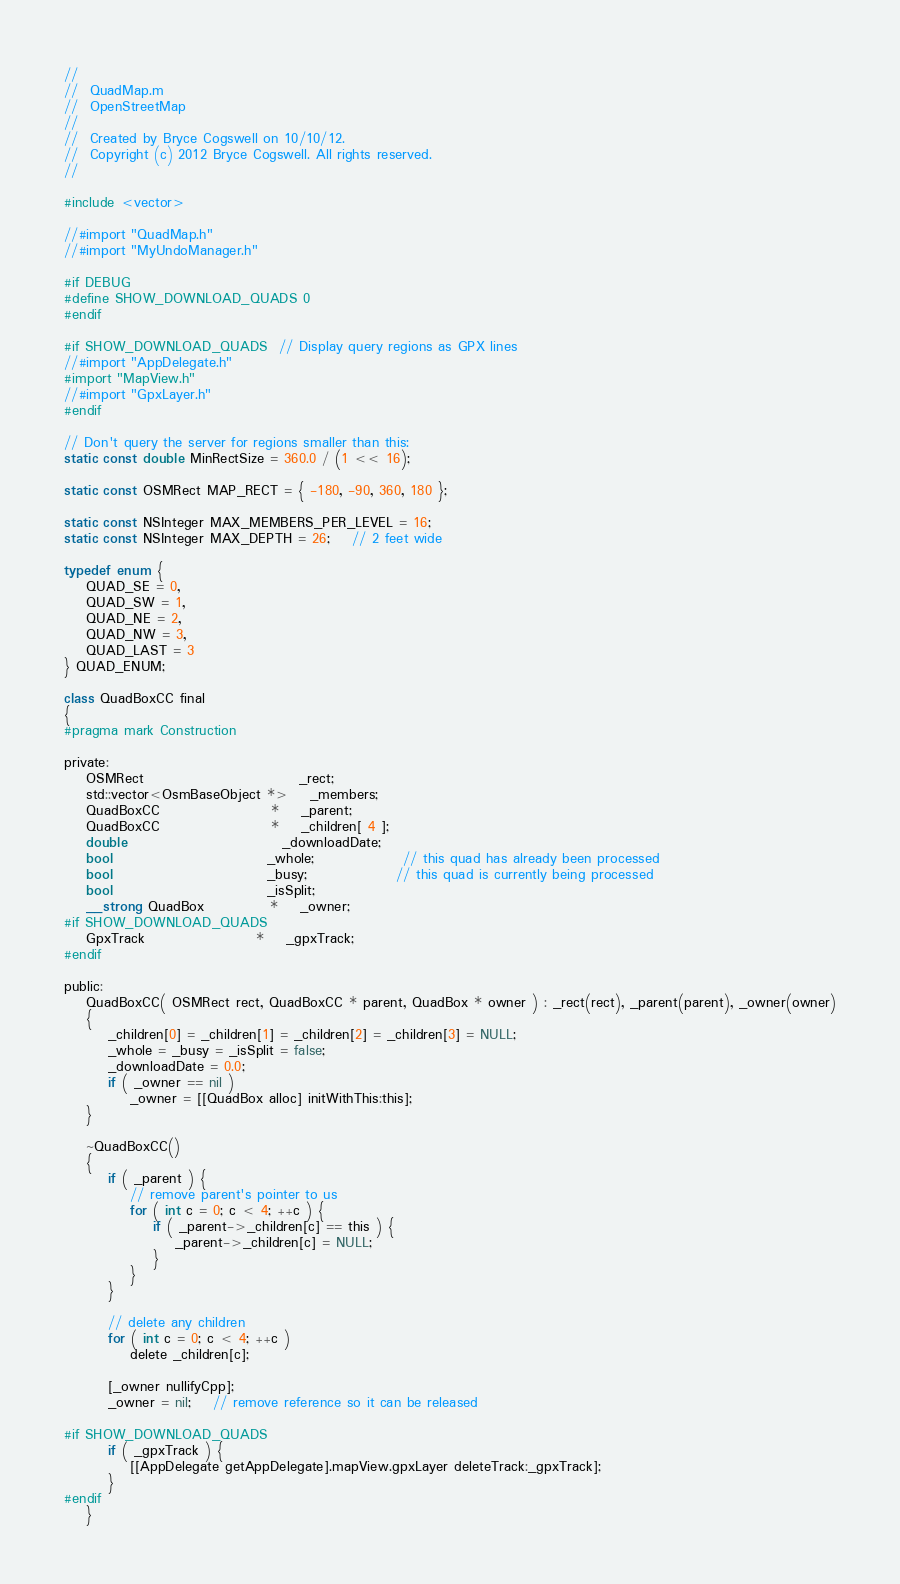Convert code to text. <code><loc_0><loc_0><loc_500><loc_500><_ObjectiveC_>//
//  QuadMap.m
//  OpenStreetMap
//
//  Created by Bryce Cogswell on 10/10/12.
//  Copyright (c) 2012 Bryce Cogswell. All rights reserved.
//

#include <vector>

//#import "QuadMap.h"
//#import "MyUndoManager.h"

#if DEBUG
#define SHOW_DOWNLOAD_QUADS 0
#endif

#if SHOW_DOWNLOAD_QUADS	// Display query regions as GPX lines
//#import "AppDelegate.h"
#import "MapView.h"
//#import "GpxLayer.h"
#endif

// Don't query the server for regions smaller than this:
static const double MinRectSize = 360.0 / (1 << 16);

static const OSMRect MAP_RECT = { -180, -90, 360, 180 };

static const NSInteger MAX_MEMBERS_PER_LEVEL = 16;
static const NSInteger MAX_DEPTH = 26;	// 2 feet wide

typedef enum {
	QUAD_SE = 0,
	QUAD_SW = 1,
	QUAD_NE = 2,
	QUAD_NW = 3,
	QUAD_LAST = 3
} QUAD_ENUM;

class QuadBoxCC final
{
#pragma mark Construction

private:
	OSMRect							_rect;
	std::vector<OsmBaseObject *>	_members;
	QuadBoxCC					*	_parent;
	QuadBoxCC					*	_children[ 4 ];
	double							_downloadDate;
	bool							_whole;				// this quad has already been processed
	bool							_busy;				// this quad is currently being processed
	bool							_isSplit;
	__strong QuadBox			*	_owner;
#if SHOW_DOWNLOAD_QUADS
	GpxTrack					*	_gpxTrack;
#endif

public:
	QuadBoxCC( OSMRect rect, QuadBoxCC * parent, QuadBox * owner ) : _rect(rect), _parent(parent), _owner(owner)
	{
		_children[0] = _children[1] = _children[2] = _children[3] = NULL;
		_whole = _busy = _isSplit = false;
		_downloadDate = 0.0;
		if ( _owner == nil )
			_owner = [[QuadBox alloc] initWithThis:this];
	}

	~QuadBoxCC()
	{
		if ( _parent ) {
			// remove parent's pointer to us
			for ( int c = 0; c < 4; ++c ) {
				if ( _parent->_children[c] == this ) {
					_parent->_children[c] = NULL;
				}
			}
		}

		// delete any children
		for ( int c = 0; c < 4; ++c )
			delete _children[c];
		
		[_owner nullifyCpp];
		_owner = nil;	// remove reference so it can be released

#if SHOW_DOWNLOAD_QUADS
		if ( _gpxTrack ) {
			[[AppDelegate getAppDelegate].mapView.gpxLayer deleteTrack:_gpxTrack];
		}
#endif
	}
</code> 